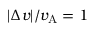Convert formula to latex. <formula><loc_0><loc_0><loc_500><loc_500>| \Delta v | / v _ { A } = 1</formula> 